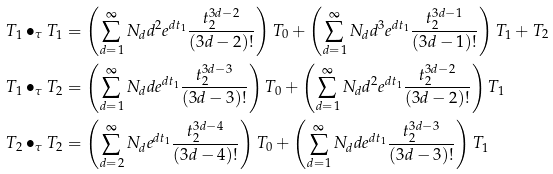Convert formula to latex. <formula><loc_0><loc_0><loc_500><loc_500>T _ { 1 } \bullet _ { \tau } T _ { 1 } & = \left ( \sum _ { d = 1 } ^ { \infty } N _ { d } d ^ { 2 } e ^ { d t _ { 1 } } \frac { t _ { 2 } ^ { 3 d - 2 } } { ( 3 d - 2 ) ! } \right ) T _ { 0 } + \left ( \sum _ { d = 1 } ^ { \infty } N _ { d } d ^ { 3 } e ^ { d t _ { 1 } } \frac { t _ { 2 } ^ { 3 d - 1 } } { ( 3 d - 1 ) ! } \right ) T _ { 1 } + T _ { 2 } \\ T _ { 1 } \bullet _ { \tau } T _ { 2 } & = \left ( \sum _ { d = 1 } ^ { \infty } N _ { d } d e ^ { d t _ { 1 } } \frac { t _ { 2 } ^ { 3 d - 3 } } { ( 3 d - 3 ) ! } \right ) T _ { 0 } + \left ( \sum _ { d = 1 } ^ { \infty } N _ { d } d ^ { 2 } e ^ { d t _ { 1 } } \frac { t _ { 2 } ^ { 3 d - 2 } } { ( 3 d - 2 ) ! } \right ) T _ { 1 } \\ T _ { 2 } \bullet _ { \tau } T _ { 2 } & = \left ( \sum _ { d = 2 } ^ { \infty } N _ { d } e ^ { d t _ { 1 } } \frac { t _ { 2 } ^ { 3 d - 4 } } { ( 3 d - 4 ) ! } \right ) T _ { 0 } + \left ( \sum _ { d = 1 } ^ { \infty } N _ { d } d e ^ { d t _ { 1 } } \frac { t _ { 2 } ^ { 3 d - 3 } } { ( 3 d - 3 ) ! } \right ) T _ { 1 }</formula> 